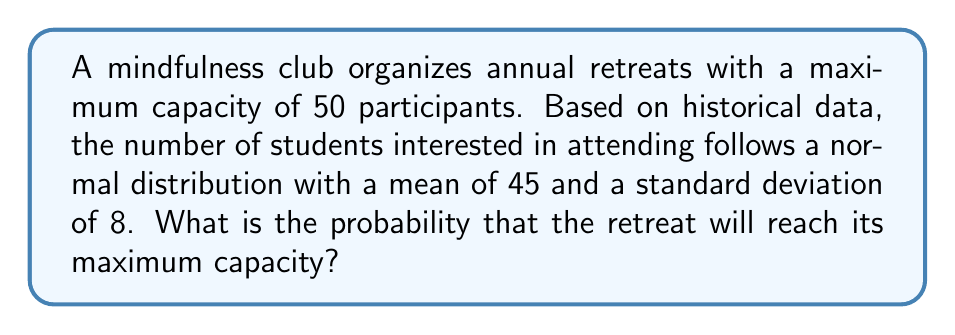Solve this math problem. To solve this problem, we need to follow these steps:

1. Identify the given information:
   - Maximum capacity: 50 participants
   - Mean (μ) = 45
   - Standard deviation (σ) = 8
   - The distribution is normal

2. We want to find the probability that the number of interested students is greater than or equal to 50.

3. Calculate the z-score for 50 participants:
   $z = \frac{x - \mu}{\sigma} = \frac{50 - 45}{8} = 0.625$

4. Use the standard normal distribution table or a calculator to find the area to the right of z = 0.625.

5. The area to the right of z = 0.625 represents the probability of reaching or exceeding maximum capacity.

6. Using a standard normal distribution table or calculator:
   $P(Z > 0.625) = 1 - P(Z < 0.625) = 1 - 0.7340 = 0.2660$

Therefore, the probability of reaching maximum retreat capacity is approximately 0.2660 or 26.60%.
Answer: 0.2660 